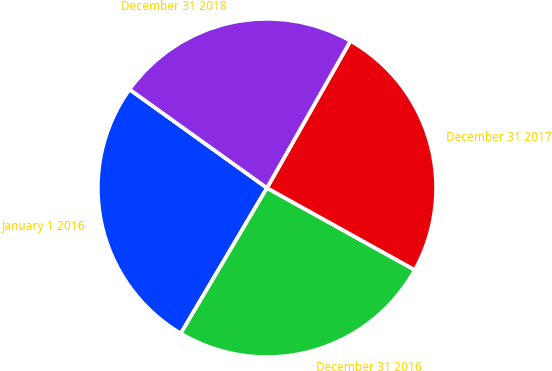Convert chart. <chart><loc_0><loc_0><loc_500><loc_500><pie_chart><fcel>January 1 2016<fcel>December 31 2016<fcel>December 31 2017<fcel>December 31 2018<nl><fcel>26.39%<fcel>25.45%<fcel>24.84%<fcel>23.32%<nl></chart> 